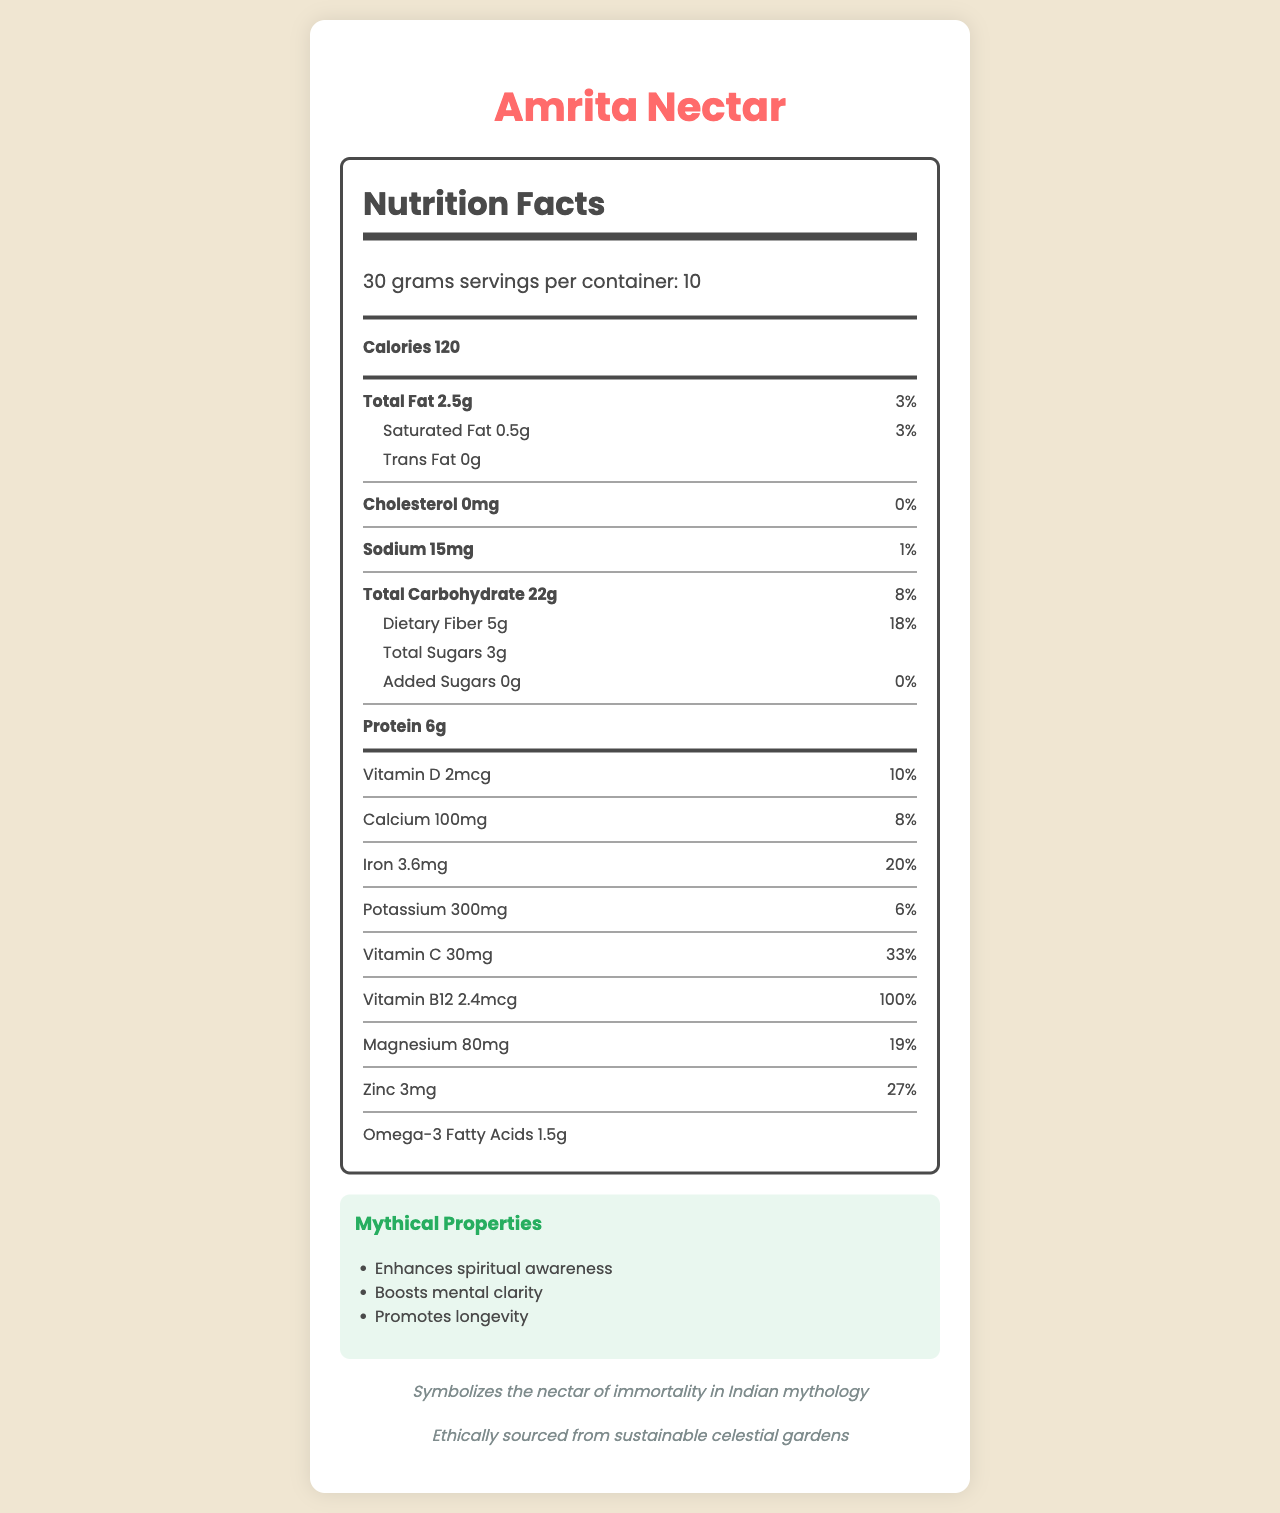what is the serving size of Amrita Nectar? The serving size is displayed at the top of the document, indicating "30 grams".
Answer: 30 grams how many calories are in one serving of Amrita Nectar? The calories per serving are listed as "120" beneath the serving info section.
Answer: 120 what is the total fat content in one serving? The total fat content is shown in the nutrition facts section, labeled as "Total Fat 2.5g".
Answer: 2.5g how much dietary fiber does each serving contain? The amount of dietary fiber per serving is detailed next to "Dietary Fiber", listed as "5g".
Answer: 5g what are the mythical properties of Amrita Nectar? The mythical properties are listed in a separate section titled "Mythical Properties".
Answer: Enhances spiritual awareness, Boosts mental clarity, Promotes longevity how much Vitamin C is present in each serving of Amrita Nectar? The Vitamin C content is detailed in the nutrition facts section, with "30mg" specifically listed.
Answer: 30mg which nutrient has the highest daily value percentage? A. Iron B. Vitamin D C. Magnesium D. Vitamin B12 Vitamin B12 has a daily value percentage of 100%, which is the highest among all the listed nutrients.
Answer: D what is the recommended usage for Amrita Nectar? A. Consume directly B. Mix with warm milk or water C. Apply on skin D. Use as an essential oil The document recommends "Mix with warm milk or water, or sprinkle over yogurt" under the recommended usage section.
Answer: B Does Amrita Nectar contain any added sugars? It's mentioned in the nutrition facts that added sugars are "0g".
Answer: No who is recommended to consume Amrita Nectar? The document does not specify any particular group of people who are recommended to consume it.
Answer: Not enough information Summarize the main idea of the document. The document outlines the nutrient analysis of Amrita Nectar, including calories, fats, carbohydrates, and various vitamins and minerals. It also describes its mythical properties, cultural background, and suggested methods of consumption.
Answer: The document provides detailed nutritional information about Amrita Nectar, a fictional superfood derived from Indian mythology, highlighting its serving size, nutrient content, mythical properties, recommended usage, and cultural significance. what is the origin of Amrita Nectar in the story? The document notes that Amrita Nectar is from the celestial tree Kalpavriksha, as mentioned in Krishna's discourse to Arjuna.
Answer: Derived from the celestial tree Kalpavriksha, mentioned in Krishna's discourse to Arjuna how does the document convey the cultural significance of Amrita Nectar? The cultural significance is explained at the bottom of the document, indicating that it symbolizes the nectar of immortality in Indian mythology.
Answer: Symbolizes the nectar of immortality in Indian mythology how is Amrita Nectar prepared according to the document? The preparation method mentioned in the document is "Sun-dried and ground into a fine powder".
Answer: Sun-dried and ground into a fine powder is there any cholesterol in Amrita Nectar? The document specifies that the cholesterol content is "0mg".
Answer: No where is Amrita Nectar ethically sourced from? The sustainability note states that it is ethically sourced from sustainable celestial gardens.
Answer: Sustainable celestial gardens Does the serving size affect the total calories listed? The total calories listed are based on the serving size of 30 grams, with 120 calories per serving.
Answer: Yes 